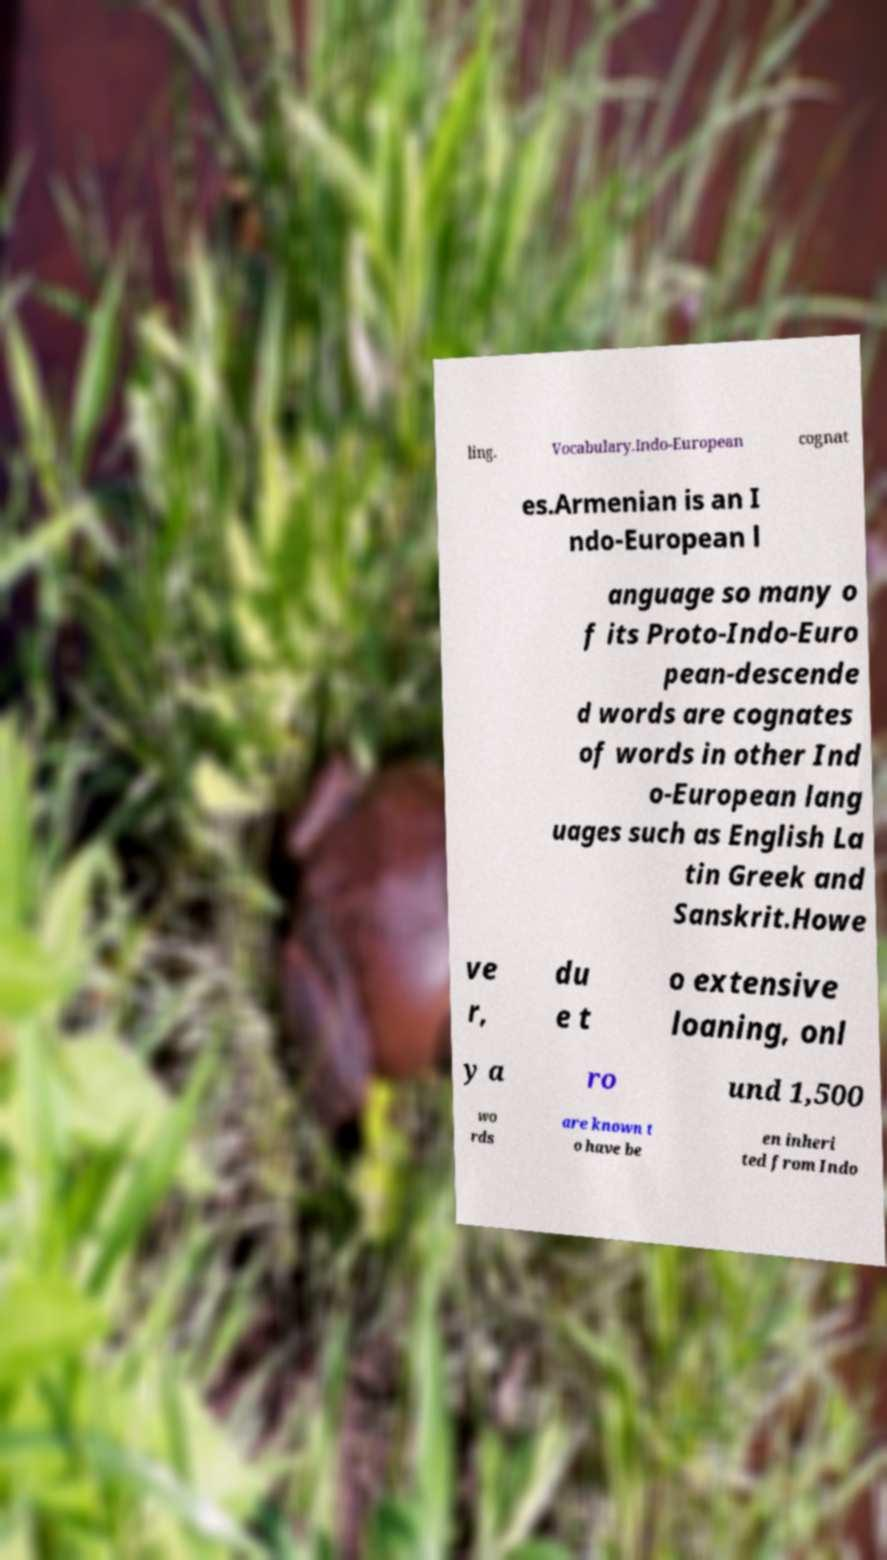Could you extract and type out the text from this image? ling. Vocabulary.Indo-European cognat es.Armenian is an I ndo-European l anguage so many o f its Proto-Indo-Euro pean-descende d words are cognates of words in other Ind o-European lang uages such as English La tin Greek and Sanskrit.Howe ve r, du e t o extensive loaning, onl y a ro und 1,500 wo rds are known t o have be en inheri ted from Indo 